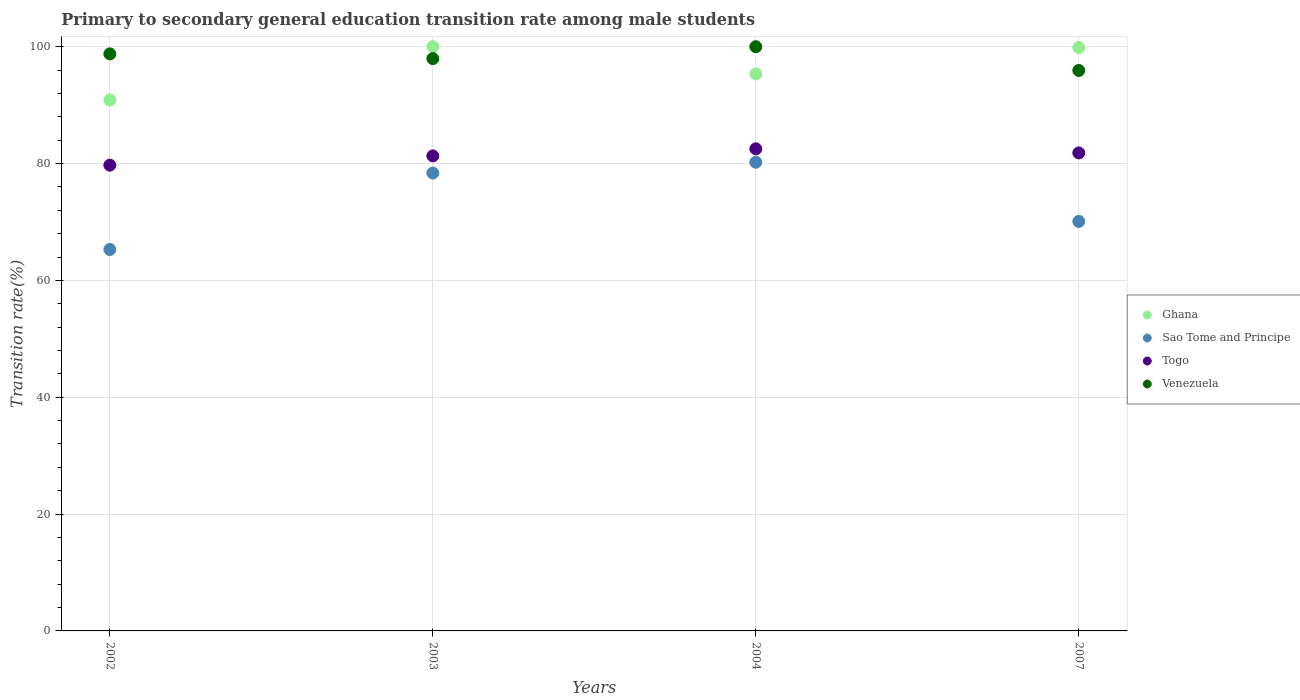How many different coloured dotlines are there?
Your answer should be compact. 4. What is the transition rate in Venezuela in 2003?
Give a very brief answer. 97.97. Across all years, what is the maximum transition rate in Ghana?
Make the answer very short. 100. Across all years, what is the minimum transition rate in Ghana?
Ensure brevity in your answer.  90.88. In which year was the transition rate in Sao Tome and Principe maximum?
Make the answer very short. 2004. In which year was the transition rate in Ghana minimum?
Your answer should be compact. 2002. What is the total transition rate in Venezuela in the graph?
Offer a terse response. 392.68. What is the difference between the transition rate in Sao Tome and Principe in 2002 and that in 2007?
Offer a terse response. -4.81. What is the difference between the transition rate in Ghana in 2004 and the transition rate in Sao Tome and Principe in 2002?
Make the answer very short. 30.05. What is the average transition rate in Sao Tome and Principe per year?
Give a very brief answer. 73.5. In the year 2003, what is the difference between the transition rate in Togo and transition rate in Ghana?
Ensure brevity in your answer.  -18.69. In how many years, is the transition rate in Venezuela greater than 64 %?
Provide a succinct answer. 4. What is the ratio of the transition rate in Togo in 2003 to that in 2007?
Provide a short and direct response. 0.99. Is the difference between the transition rate in Togo in 2004 and 2007 greater than the difference between the transition rate in Ghana in 2004 and 2007?
Keep it short and to the point. Yes. What is the difference between the highest and the second highest transition rate in Ghana?
Offer a very short reply. 0.13. What is the difference between the highest and the lowest transition rate in Venezuela?
Offer a terse response. 4.07. Is the sum of the transition rate in Togo in 2002 and 2003 greater than the maximum transition rate in Sao Tome and Principe across all years?
Ensure brevity in your answer.  Yes. Does the transition rate in Ghana monotonically increase over the years?
Keep it short and to the point. No. Is the transition rate in Ghana strictly greater than the transition rate in Venezuela over the years?
Offer a terse response. No. How many dotlines are there?
Offer a very short reply. 4. Does the graph contain any zero values?
Your response must be concise. No. Where does the legend appear in the graph?
Your answer should be compact. Center right. How are the legend labels stacked?
Your answer should be compact. Vertical. What is the title of the graph?
Provide a short and direct response. Primary to secondary general education transition rate among male students. What is the label or title of the X-axis?
Your answer should be very brief. Years. What is the label or title of the Y-axis?
Ensure brevity in your answer.  Transition rate(%). What is the Transition rate(%) of Ghana in 2002?
Give a very brief answer. 90.88. What is the Transition rate(%) in Sao Tome and Principe in 2002?
Ensure brevity in your answer.  65.29. What is the Transition rate(%) of Togo in 2002?
Your answer should be compact. 79.73. What is the Transition rate(%) in Venezuela in 2002?
Ensure brevity in your answer.  98.78. What is the Transition rate(%) of Ghana in 2003?
Provide a short and direct response. 100. What is the Transition rate(%) in Sao Tome and Principe in 2003?
Keep it short and to the point. 78.38. What is the Transition rate(%) of Togo in 2003?
Your answer should be compact. 81.31. What is the Transition rate(%) of Venezuela in 2003?
Provide a short and direct response. 97.97. What is the Transition rate(%) of Ghana in 2004?
Your response must be concise. 95.34. What is the Transition rate(%) in Sao Tome and Principe in 2004?
Provide a succinct answer. 80.23. What is the Transition rate(%) in Togo in 2004?
Provide a short and direct response. 82.52. What is the Transition rate(%) in Venezuela in 2004?
Your answer should be compact. 100. What is the Transition rate(%) in Ghana in 2007?
Keep it short and to the point. 99.87. What is the Transition rate(%) in Sao Tome and Principe in 2007?
Offer a very short reply. 70.1. What is the Transition rate(%) in Togo in 2007?
Provide a succinct answer. 81.82. What is the Transition rate(%) in Venezuela in 2007?
Offer a terse response. 95.93. Across all years, what is the maximum Transition rate(%) of Sao Tome and Principe?
Give a very brief answer. 80.23. Across all years, what is the maximum Transition rate(%) in Togo?
Offer a very short reply. 82.52. Across all years, what is the maximum Transition rate(%) of Venezuela?
Ensure brevity in your answer.  100. Across all years, what is the minimum Transition rate(%) in Ghana?
Keep it short and to the point. 90.88. Across all years, what is the minimum Transition rate(%) in Sao Tome and Principe?
Your answer should be very brief. 65.29. Across all years, what is the minimum Transition rate(%) of Togo?
Your response must be concise. 79.73. Across all years, what is the minimum Transition rate(%) in Venezuela?
Provide a short and direct response. 95.93. What is the total Transition rate(%) of Ghana in the graph?
Provide a short and direct response. 386.09. What is the total Transition rate(%) in Sao Tome and Principe in the graph?
Offer a very short reply. 293.99. What is the total Transition rate(%) of Togo in the graph?
Your answer should be compact. 325.39. What is the total Transition rate(%) of Venezuela in the graph?
Your answer should be very brief. 392.68. What is the difference between the Transition rate(%) of Ghana in 2002 and that in 2003?
Ensure brevity in your answer.  -9.12. What is the difference between the Transition rate(%) of Sao Tome and Principe in 2002 and that in 2003?
Keep it short and to the point. -13.09. What is the difference between the Transition rate(%) in Togo in 2002 and that in 2003?
Your answer should be compact. -1.58. What is the difference between the Transition rate(%) in Venezuela in 2002 and that in 2003?
Ensure brevity in your answer.  0.81. What is the difference between the Transition rate(%) of Ghana in 2002 and that in 2004?
Provide a succinct answer. -4.46. What is the difference between the Transition rate(%) of Sao Tome and Principe in 2002 and that in 2004?
Keep it short and to the point. -14.94. What is the difference between the Transition rate(%) in Togo in 2002 and that in 2004?
Keep it short and to the point. -2.8. What is the difference between the Transition rate(%) in Venezuela in 2002 and that in 2004?
Offer a very short reply. -1.22. What is the difference between the Transition rate(%) in Ghana in 2002 and that in 2007?
Your answer should be very brief. -8.98. What is the difference between the Transition rate(%) of Sao Tome and Principe in 2002 and that in 2007?
Provide a short and direct response. -4.81. What is the difference between the Transition rate(%) in Togo in 2002 and that in 2007?
Give a very brief answer. -2.1. What is the difference between the Transition rate(%) in Venezuela in 2002 and that in 2007?
Your answer should be very brief. 2.85. What is the difference between the Transition rate(%) of Ghana in 2003 and that in 2004?
Your response must be concise. 4.66. What is the difference between the Transition rate(%) in Sao Tome and Principe in 2003 and that in 2004?
Ensure brevity in your answer.  -1.85. What is the difference between the Transition rate(%) in Togo in 2003 and that in 2004?
Make the answer very short. -1.21. What is the difference between the Transition rate(%) of Venezuela in 2003 and that in 2004?
Make the answer very short. -2.03. What is the difference between the Transition rate(%) of Ghana in 2003 and that in 2007?
Give a very brief answer. 0.13. What is the difference between the Transition rate(%) of Sao Tome and Principe in 2003 and that in 2007?
Make the answer very short. 8.28. What is the difference between the Transition rate(%) in Togo in 2003 and that in 2007?
Keep it short and to the point. -0.51. What is the difference between the Transition rate(%) of Venezuela in 2003 and that in 2007?
Provide a succinct answer. 2.03. What is the difference between the Transition rate(%) of Ghana in 2004 and that in 2007?
Your answer should be very brief. -4.52. What is the difference between the Transition rate(%) in Sao Tome and Principe in 2004 and that in 2007?
Provide a short and direct response. 10.13. What is the difference between the Transition rate(%) in Togo in 2004 and that in 2007?
Keep it short and to the point. 0.7. What is the difference between the Transition rate(%) of Venezuela in 2004 and that in 2007?
Give a very brief answer. 4.07. What is the difference between the Transition rate(%) of Ghana in 2002 and the Transition rate(%) of Sao Tome and Principe in 2003?
Your response must be concise. 12.51. What is the difference between the Transition rate(%) of Ghana in 2002 and the Transition rate(%) of Togo in 2003?
Your answer should be compact. 9.57. What is the difference between the Transition rate(%) of Ghana in 2002 and the Transition rate(%) of Venezuela in 2003?
Ensure brevity in your answer.  -7.08. What is the difference between the Transition rate(%) of Sao Tome and Principe in 2002 and the Transition rate(%) of Togo in 2003?
Your answer should be compact. -16.02. What is the difference between the Transition rate(%) of Sao Tome and Principe in 2002 and the Transition rate(%) of Venezuela in 2003?
Provide a short and direct response. -32.68. What is the difference between the Transition rate(%) of Togo in 2002 and the Transition rate(%) of Venezuela in 2003?
Ensure brevity in your answer.  -18.24. What is the difference between the Transition rate(%) of Ghana in 2002 and the Transition rate(%) of Sao Tome and Principe in 2004?
Offer a terse response. 10.66. What is the difference between the Transition rate(%) of Ghana in 2002 and the Transition rate(%) of Togo in 2004?
Keep it short and to the point. 8.36. What is the difference between the Transition rate(%) in Ghana in 2002 and the Transition rate(%) in Venezuela in 2004?
Ensure brevity in your answer.  -9.12. What is the difference between the Transition rate(%) of Sao Tome and Principe in 2002 and the Transition rate(%) of Togo in 2004?
Provide a succinct answer. -17.23. What is the difference between the Transition rate(%) of Sao Tome and Principe in 2002 and the Transition rate(%) of Venezuela in 2004?
Keep it short and to the point. -34.71. What is the difference between the Transition rate(%) in Togo in 2002 and the Transition rate(%) in Venezuela in 2004?
Provide a short and direct response. -20.27. What is the difference between the Transition rate(%) of Ghana in 2002 and the Transition rate(%) of Sao Tome and Principe in 2007?
Offer a very short reply. 20.78. What is the difference between the Transition rate(%) in Ghana in 2002 and the Transition rate(%) in Togo in 2007?
Give a very brief answer. 9.06. What is the difference between the Transition rate(%) of Ghana in 2002 and the Transition rate(%) of Venezuela in 2007?
Provide a short and direct response. -5.05. What is the difference between the Transition rate(%) of Sao Tome and Principe in 2002 and the Transition rate(%) of Togo in 2007?
Your answer should be compact. -16.53. What is the difference between the Transition rate(%) in Sao Tome and Principe in 2002 and the Transition rate(%) in Venezuela in 2007?
Your answer should be very brief. -30.64. What is the difference between the Transition rate(%) of Togo in 2002 and the Transition rate(%) of Venezuela in 2007?
Offer a terse response. -16.21. What is the difference between the Transition rate(%) of Ghana in 2003 and the Transition rate(%) of Sao Tome and Principe in 2004?
Offer a very short reply. 19.77. What is the difference between the Transition rate(%) in Ghana in 2003 and the Transition rate(%) in Togo in 2004?
Make the answer very short. 17.48. What is the difference between the Transition rate(%) in Sao Tome and Principe in 2003 and the Transition rate(%) in Togo in 2004?
Offer a very short reply. -4.15. What is the difference between the Transition rate(%) of Sao Tome and Principe in 2003 and the Transition rate(%) of Venezuela in 2004?
Your answer should be very brief. -21.62. What is the difference between the Transition rate(%) in Togo in 2003 and the Transition rate(%) in Venezuela in 2004?
Offer a very short reply. -18.69. What is the difference between the Transition rate(%) of Ghana in 2003 and the Transition rate(%) of Sao Tome and Principe in 2007?
Provide a succinct answer. 29.9. What is the difference between the Transition rate(%) of Ghana in 2003 and the Transition rate(%) of Togo in 2007?
Your answer should be compact. 18.18. What is the difference between the Transition rate(%) in Ghana in 2003 and the Transition rate(%) in Venezuela in 2007?
Your answer should be compact. 4.07. What is the difference between the Transition rate(%) in Sao Tome and Principe in 2003 and the Transition rate(%) in Togo in 2007?
Provide a succinct answer. -3.45. What is the difference between the Transition rate(%) of Sao Tome and Principe in 2003 and the Transition rate(%) of Venezuela in 2007?
Offer a very short reply. -17.56. What is the difference between the Transition rate(%) of Togo in 2003 and the Transition rate(%) of Venezuela in 2007?
Make the answer very short. -14.62. What is the difference between the Transition rate(%) of Ghana in 2004 and the Transition rate(%) of Sao Tome and Principe in 2007?
Give a very brief answer. 25.24. What is the difference between the Transition rate(%) in Ghana in 2004 and the Transition rate(%) in Togo in 2007?
Your response must be concise. 13.52. What is the difference between the Transition rate(%) in Ghana in 2004 and the Transition rate(%) in Venezuela in 2007?
Provide a succinct answer. -0.59. What is the difference between the Transition rate(%) in Sao Tome and Principe in 2004 and the Transition rate(%) in Togo in 2007?
Keep it short and to the point. -1.6. What is the difference between the Transition rate(%) in Sao Tome and Principe in 2004 and the Transition rate(%) in Venezuela in 2007?
Offer a very short reply. -15.71. What is the difference between the Transition rate(%) of Togo in 2004 and the Transition rate(%) of Venezuela in 2007?
Your answer should be very brief. -13.41. What is the average Transition rate(%) of Ghana per year?
Give a very brief answer. 96.52. What is the average Transition rate(%) of Sao Tome and Principe per year?
Give a very brief answer. 73.5. What is the average Transition rate(%) in Togo per year?
Keep it short and to the point. 81.35. What is the average Transition rate(%) in Venezuela per year?
Keep it short and to the point. 98.17. In the year 2002, what is the difference between the Transition rate(%) of Ghana and Transition rate(%) of Sao Tome and Principe?
Your response must be concise. 25.59. In the year 2002, what is the difference between the Transition rate(%) of Ghana and Transition rate(%) of Togo?
Your response must be concise. 11.16. In the year 2002, what is the difference between the Transition rate(%) in Ghana and Transition rate(%) in Venezuela?
Ensure brevity in your answer.  -7.89. In the year 2002, what is the difference between the Transition rate(%) of Sao Tome and Principe and Transition rate(%) of Togo?
Make the answer very short. -14.44. In the year 2002, what is the difference between the Transition rate(%) of Sao Tome and Principe and Transition rate(%) of Venezuela?
Make the answer very short. -33.49. In the year 2002, what is the difference between the Transition rate(%) of Togo and Transition rate(%) of Venezuela?
Your answer should be very brief. -19.05. In the year 2003, what is the difference between the Transition rate(%) in Ghana and Transition rate(%) in Sao Tome and Principe?
Make the answer very short. 21.62. In the year 2003, what is the difference between the Transition rate(%) of Ghana and Transition rate(%) of Togo?
Provide a succinct answer. 18.69. In the year 2003, what is the difference between the Transition rate(%) of Ghana and Transition rate(%) of Venezuela?
Offer a terse response. 2.03. In the year 2003, what is the difference between the Transition rate(%) of Sao Tome and Principe and Transition rate(%) of Togo?
Give a very brief answer. -2.94. In the year 2003, what is the difference between the Transition rate(%) in Sao Tome and Principe and Transition rate(%) in Venezuela?
Offer a very short reply. -19.59. In the year 2003, what is the difference between the Transition rate(%) of Togo and Transition rate(%) of Venezuela?
Give a very brief answer. -16.65. In the year 2004, what is the difference between the Transition rate(%) of Ghana and Transition rate(%) of Sao Tome and Principe?
Your answer should be compact. 15.12. In the year 2004, what is the difference between the Transition rate(%) in Ghana and Transition rate(%) in Togo?
Give a very brief answer. 12.82. In the year 2004, what is the difference between the Transition rate(%) of Ghana and Transition rate(%) of Venezuela?
Your answer should be very brief. -4.66. In the year 2004, what is the difference between the Transition rate(%) in Sao Tome and Principe and Transition rate(%) in Togo?
Offer a terse response. -2.3. In the year 2004, what is the difference between the Transition rate(%) of Sao Tome and Principe and Transition rate(%) of Venezuela?
Offer a very short reply. -19.77. In the year 2004, what is the difference between the Transition rate(%) in Togo and Transition rate(%) in Venezuela?
Provide a succinct answer. -17.48. In the year 2007, what is the difference between the Transition rate(%) in Ghana and Transition rate(%) in Sao Tome and Principe?
Your response must be concise. 29.77. In the year 2007, what is the difference between the Transition rate(%) in Ghana and Transition rate(%) in Togo?
Offer a very short reply. 18.04. In the year 2007, what is the difference between the Transition rate(%) of Ghana and Transition rate(%) of Venezuela?
Provide a short and direct response. 3.93. In the year 2007, what is the difference between the Transition rate(%) of Sao Tome and Principe and Transition rate(%) of Togo?
Your answer should be compact. -11.72. In the year 2007, what is the difference between the Transition rate(%) of Sao Tome and Principe and Transition rate(%) of Venezuela?
Offer a terse response. -25.83. In the year 2007, what is the difference between the Transition rate(%) of Togo and Transition rate(%) of Venezuela?
Provide a succinct answer. -14.11. What is the ratio of the Transition rate(%) of Ghana in 2002 to that in 2003?
Offer a very short reply. 0.91. What is the ratio of the Transition rate(%) of Sao Tome and Principe in 2002 to that in 2003?
Your answer should be very brief. 0.83. What is the ratio of the Transition rate(%) in Togo in 2002 to that in 2003?
Make the answer very short. 0.98. What is the ratio of the Transition rate(%) in Venezuela in 2002 to that in 2003?
Your answer should be compact. 1.01. What is the ratio of the Transition rate(%) in Ghana in 2002 to that in 2004?
Keep it short and to the point. 0.95. What is the ratio of the Transition rate(%) of Sao Tome and Principe in 2002 to that in 2004?
Offer a terse response. 0.81. What is the ratio of the Transition rate(%) in Togo in 2002 to that in 2004?
Your answer should be compact. 0.97. What is the ratio of the Transition rate(%) of Venezuela in 2002 to that in 2004?
Give a very brief answer. 0.99. What is the ratio of the Transition rate(%) of Ghana in 2002 to that in 2007?
Your answer should be compact. 0.91. What is the ratio of the Transition rate(%) of Sao Tome and Principe in 2002 to that in 2007?
Your answer should be very brief. 0.93. What is the ratio of the Transition rate(%) of Togo in 2002 to that in 2007?
Ensure brevity in your answer.  0.97. What is the ratio of the Transition rate(%) in Venezuela in 2002 to that in 2007?
Your response must be concise. 1.03. What is the ratio of the Transition rate(%) of Ghana in 2003 to that in 2004?
Provide a short and direct response. 1.05. What is the ratio of the Transition rate(%) of Sao Tome and Principe in 2003 to that in 2004?
Provide a succinct answer. 0.98. What is the ratio of the Transition rate(%) in Venezuela in 2003 to that in 2004?
Make the answer very short. 0.98. What is the ratio of the Transition rate(%) of Sao Tome and Principe in 2003 to that in 2007?
Provide a short and direct response. 1.12. What is the ratio of the Transition rate(%) in Togo in 2003 to that in 2007?
Offer a very short reply. 0.99. What is the ratio of the Transition rate(%) in Venezuela in 2003 to that in 2007?
Your answer should be very brief. 1.02. What is the ratio of the Transition rate(%) in Ghana in 2004 to that in 2007?
Keep it short and to the point. 0.95. What is the ratio of the Transition rate(%) of Sao Tome and Principe in 2004 to that in 2007?
Provide a succinct answer. 1.14. What is the ratio of the Transition rate(%) in Togo in 2004 to that in 2007?
Provide a short and direct response. 1.01. What is the ratio of the Transition rate(%) of Venezuela in 2004 to that in 2007?
Provide a short and direct response. 1.04. What is the difference between the highest and the second highest Transition rate(%) of Ghana?
Offer a very short reply. 0.13. What is the difference between the highest and the second highest Transition rate(%) of Sao Tome and Principe?
Give a very brief answer. 1.85. What is the difference between the highest and the second highest Transition rate(%) of Togo?
Your answer should be very brief. 0.7. What is the difference between the highest and the second highest Transition rate(%) in Venezuela?
Keep it short and to the point. 1.22. What is the difference between the highest and the lowest Transition rate(%) in Ghana?
Provide a short and direct response. 9.12. What is the difference between the highest and the lowest Transition rate(%) in Sao Tome and Principe?
Keep it short and to the point. 14.94. What is the difference between the highest and the lowest Transition rate(%) of Togo?
Ensure brevity in your answer.  2.8. What is the difference between the highest and the lowest Transition rate(%) in Venezuela?
Keep it short and to the point. 4.07. 